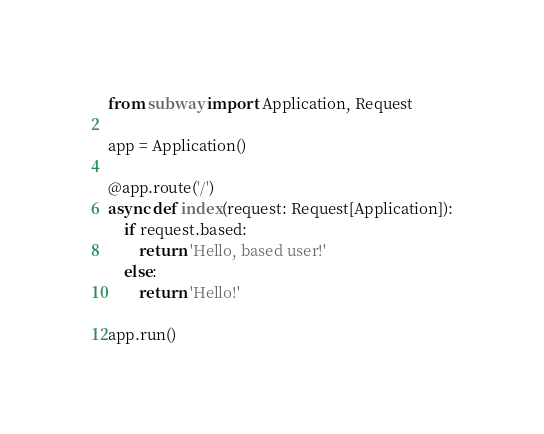<code> <loc_0><loc_0><loc_500><loc_500><_Python_>from subway import Application, Request

app = Application()

@app.route('/')
async def index(request: Request[Application]):
    if request.based:
        return 'Hello, based user!'
    else:
        return 'Hello!'

app.run()
</code> 